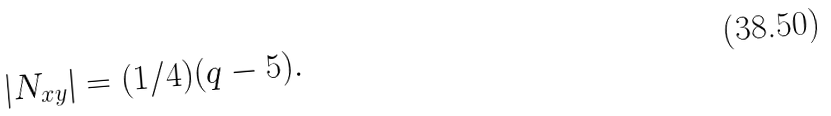<formula> <loc_0><loc_0><loc_500><loc_500>| N _ { x y } | = ( 1 / 4 ) ( q - 5 ) .</formula> 